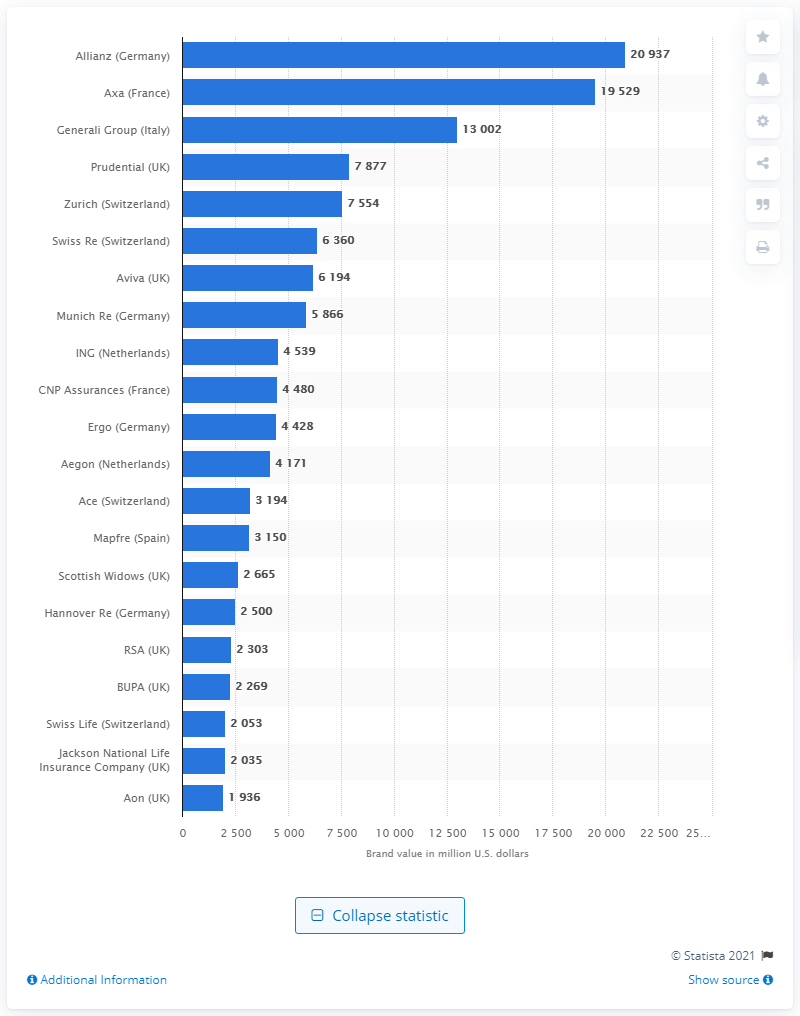List a handful of essential elements in this visual. Allianz's brand value in U.S. dollars was approximately 2,093.7. 